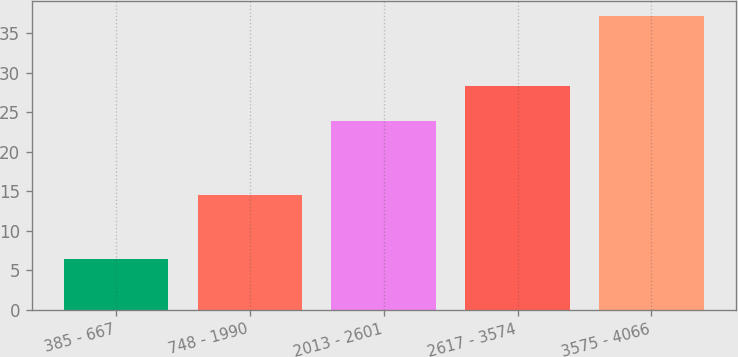Convert chart to OTSL. <chart><loc_0><loc_0><loc_500><loc_500><bar_chart><fcel>385 - 667<fcel>748 - 1990<fcel>2013 - 2601<fcel>2617 - 3574<fcel>3575 - 4066<nl><fcel>6.47<fcel>14.48<fcel>23.92<fcel>28.3<fcel>37.22<nl></chart> 